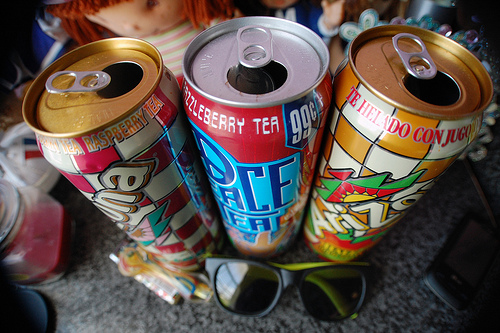<image>
Is the beverage in front of the sunglasses? No. The beverage is not in front of the sunglasses. The spatial positioning shows a different relationship between these objects. Where is the can in relation to the phone? Is it to the left of the phone? Yes. From this viewpoint, the can is positioned to the left side relative to the phone. 